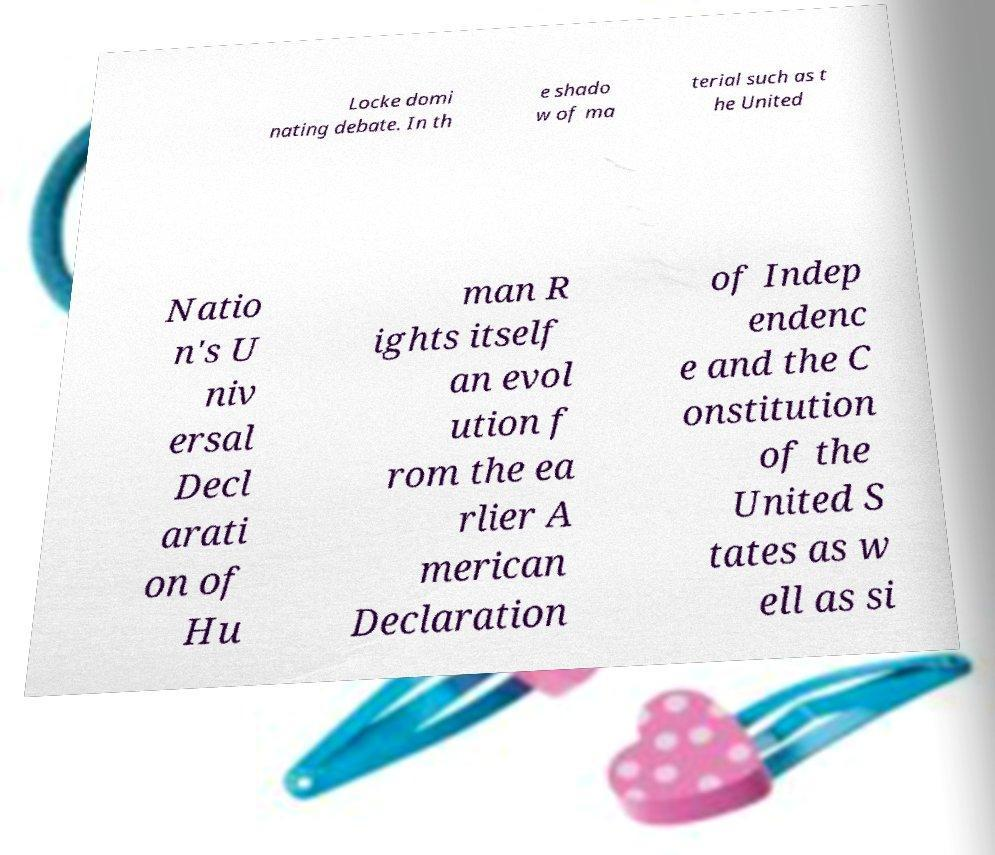There's text embedded in this image that I need extracted. Can you transcribe it verbatim? Locke domi nating debate. In th e shado w of ma terial such as t he United Natio n's U niv ersal Decl arati on of Hu man R ights itself an evol ution f rom the ea rlier A merican Declaration of Indep endenc e and the C onstitution of the United S tates as w ell as si 